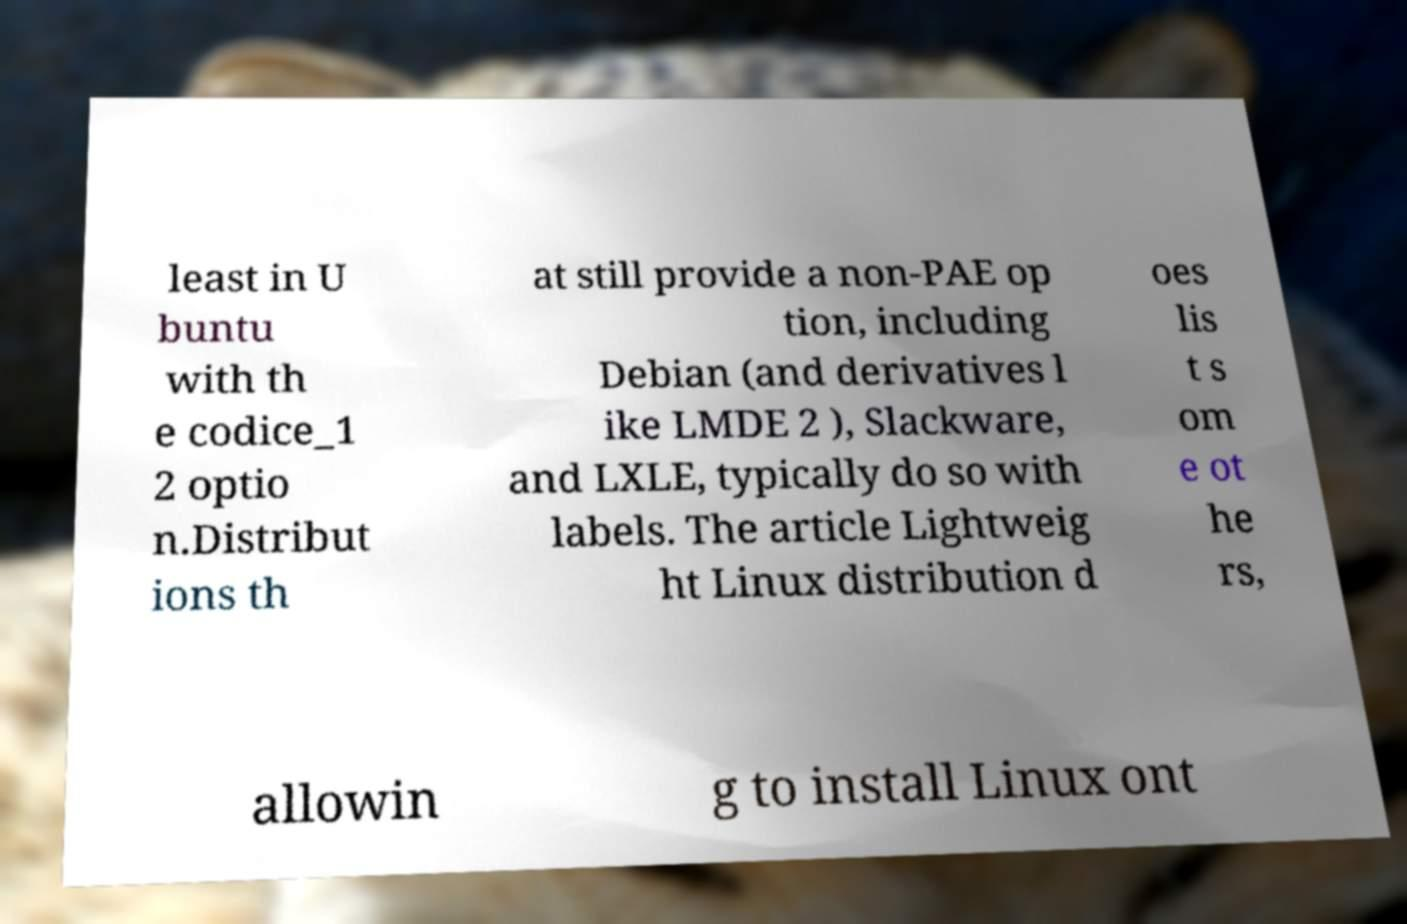There's text embedded in this image that I need extracted. Can you transcribe it verbatim? least in U buntu with th e codice_1 2 optio n.Distribut ions th at still provide a non-PAE op tion, including Debian (and derivatives l ike LMDE 2 ), Slackware, and LXLE, typically do so with labels. The article Lightweig ht Linux distribution d oes lis t s om e ot he rs, allowin g to install Linux ont 